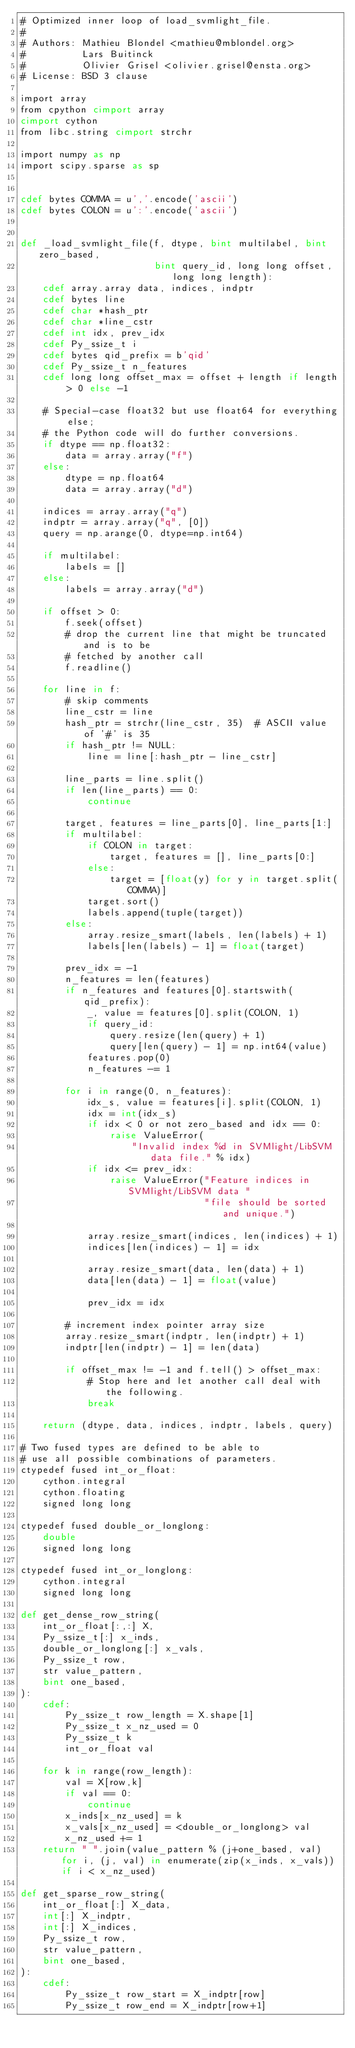Convert code to text. <code><loc_0><loc_0><loc_500><loc_500><_Cython_># Optimized inner loop of load_svmlight_file.
#
# Authors: Mathieu Blondel <mathieu@mblondel.org>
#          Lars Buitinck
#          Olivier Grisel <olivier.grisel@ensta.org>
# License: BSD 3 clause

import array
from cpython cimport array
cimport cython
from libc.string cimport strchr

import numpy as np
import scipy.sparse as sp


cdef bytes COMMA = u','.encode('ascii')
cdef bytes COLON = u':'.encode('ascii')


def _load_svmlight_file(f, dtype, bint multilabel, bint zero_based,
                        bint query_id, long long offset, long long length):
    cdef array.array data, indices, indptr
    cdef bytes line
    cdef char *hash_ptr
    cdef char *line_cstr
    cdef int idx, prev_idx
    cdef Py_ssize_t i
    cdef bytes qid_prefix = b'qid'
    cdef Py_ssize_t n_features
    cdef long long offset_max = offset + length if length > 0 else -1

    # Special-case float32 but use float64 for everything else;
    # the Python code will do further conversions.
    if dtype == np.float32:
        data = array.array("f")
    else:
        dtype = np.float64
        data = array.array("d")

    indices = array.array("q")
    indptr = array.array("q", [0])
    query = np.arange(0, dtype=np.int64)

    if multilabel:
        labels = []
    else:
        labels = array.array("d")

    if offset > 0:
        f.seek(offset)
        # drop the current line that might be truncated and is to be
        # fetched by another call
        f.readline()

    for line in f:
        # skip comments
        line_cstr = line
        hash_ptr = strchr(line_cstr, 35)  # ASCII value of '#' is 35
        if hash_ptr != NULL:
            line = line[:hash_ptr - line_cstr]

        line_parts = line.split()
        if len(line_parts) == 0:
            continue

        target, features = line_parts[0], line_parts[1:]
        if multilabel:
            if COLON in target:
                target, features = [], line_parts[0:]
            else:
                target = [float(y) for y in target.split(COMMA)]
            target.sort()
            labels.append(tuple(target))
        else:
            array.resize_smart(labels, len(labels) + 1)
            labels[len(labels) - 1] = float(target)

        prev_idx = -1
        n_features = len(features)
        if n_features and features[0].startswith(qid_prefix):
            _, value = features[0].split(COLON, 1)
            if query_id:
                query.resize(len(query) + 1)
                query[len(query) - 1] = np.int64(value)
            features.pop(0)
            n_features -= 1

        for i in range(0, n_features):
            idx_s, value = features[i].split(COLON, 1)
            idx = int(idx_s)
            if idx < 0 or not zero_based and idx == 0:
                raise ValueError(
                    "Invalid index %d in SVMlight/LibSVM data file." % idx)
            if idx <= prev_idx:
                raise ValueError("Feature indices in SVMlight/LibSVM data "
                                 "file should be sorted and unique.")

            array.resize_smart(indices, len(indices) + 1)
            indices[len(indices) - 1] = idx

            array.resize_smart(data, len(data) + 1)
            data[len(data) - 1] = float(value)

            prev_idx = idx

        # increment index pointer array size
        array.resize_smart(indptr, len(indptr) + 1)
        indptr[len(indptr) - 1] = len(data)

        if offset_max != -1 and f.tell() > offset_max:
            # Stop here and let another call deal with the following.
            break

    return (dtype, data, indices, indptr, labels, query)

# Two fused types are defined to be able to
# use all possible combinations of parameters.
ctypedef fused int_or_float:
    cython.integral
    cython.floating
    signed long long

ctypedef fused double_or_longlong:
    double
    signed long long

ctypedef fused int_or_longlong:
    cython.integral
    signed long long

def get_dense_row_string(
    int_or_float[:,:] X,
    Py_ssize_t[:] x_inds,
    double_or_longlong[:] x_vals,
    Py_ssize_t row,
    str value_pattern,
    bint one_based,
):
    cdef:
        Py_ssize_t row_length = X.shape[1]
        Py_ssize_t x_nz_used = 0
        Py_ssize_t k
        int_or_float val

    for k in range(row_length):
        val = X[row,k]
        if val == 0:
            continue
        x_inds[x_nz_used] = k
        x_vals[x_nz_used] = <double_or_longlong> val
        x_nz_used += 1
    return " ".join(value_pattern % (j+one_based, val) for i, (j, val) in enumerate(zip(x_inds, x_vals)) if i < x_nz_used)

def get_sparse_row_string(
    int_or_float[:] X_data,
    int[:] X_indptr,
    int[:] X_indices,
    Py_ssize_t row,
    str value_pattern,
    bint one_based,
):
    cdef:
        Py_ssize_t row_start = X_indptr[row]
        Py_ssize_t row_end = X_indptr[row+1]
</code> 